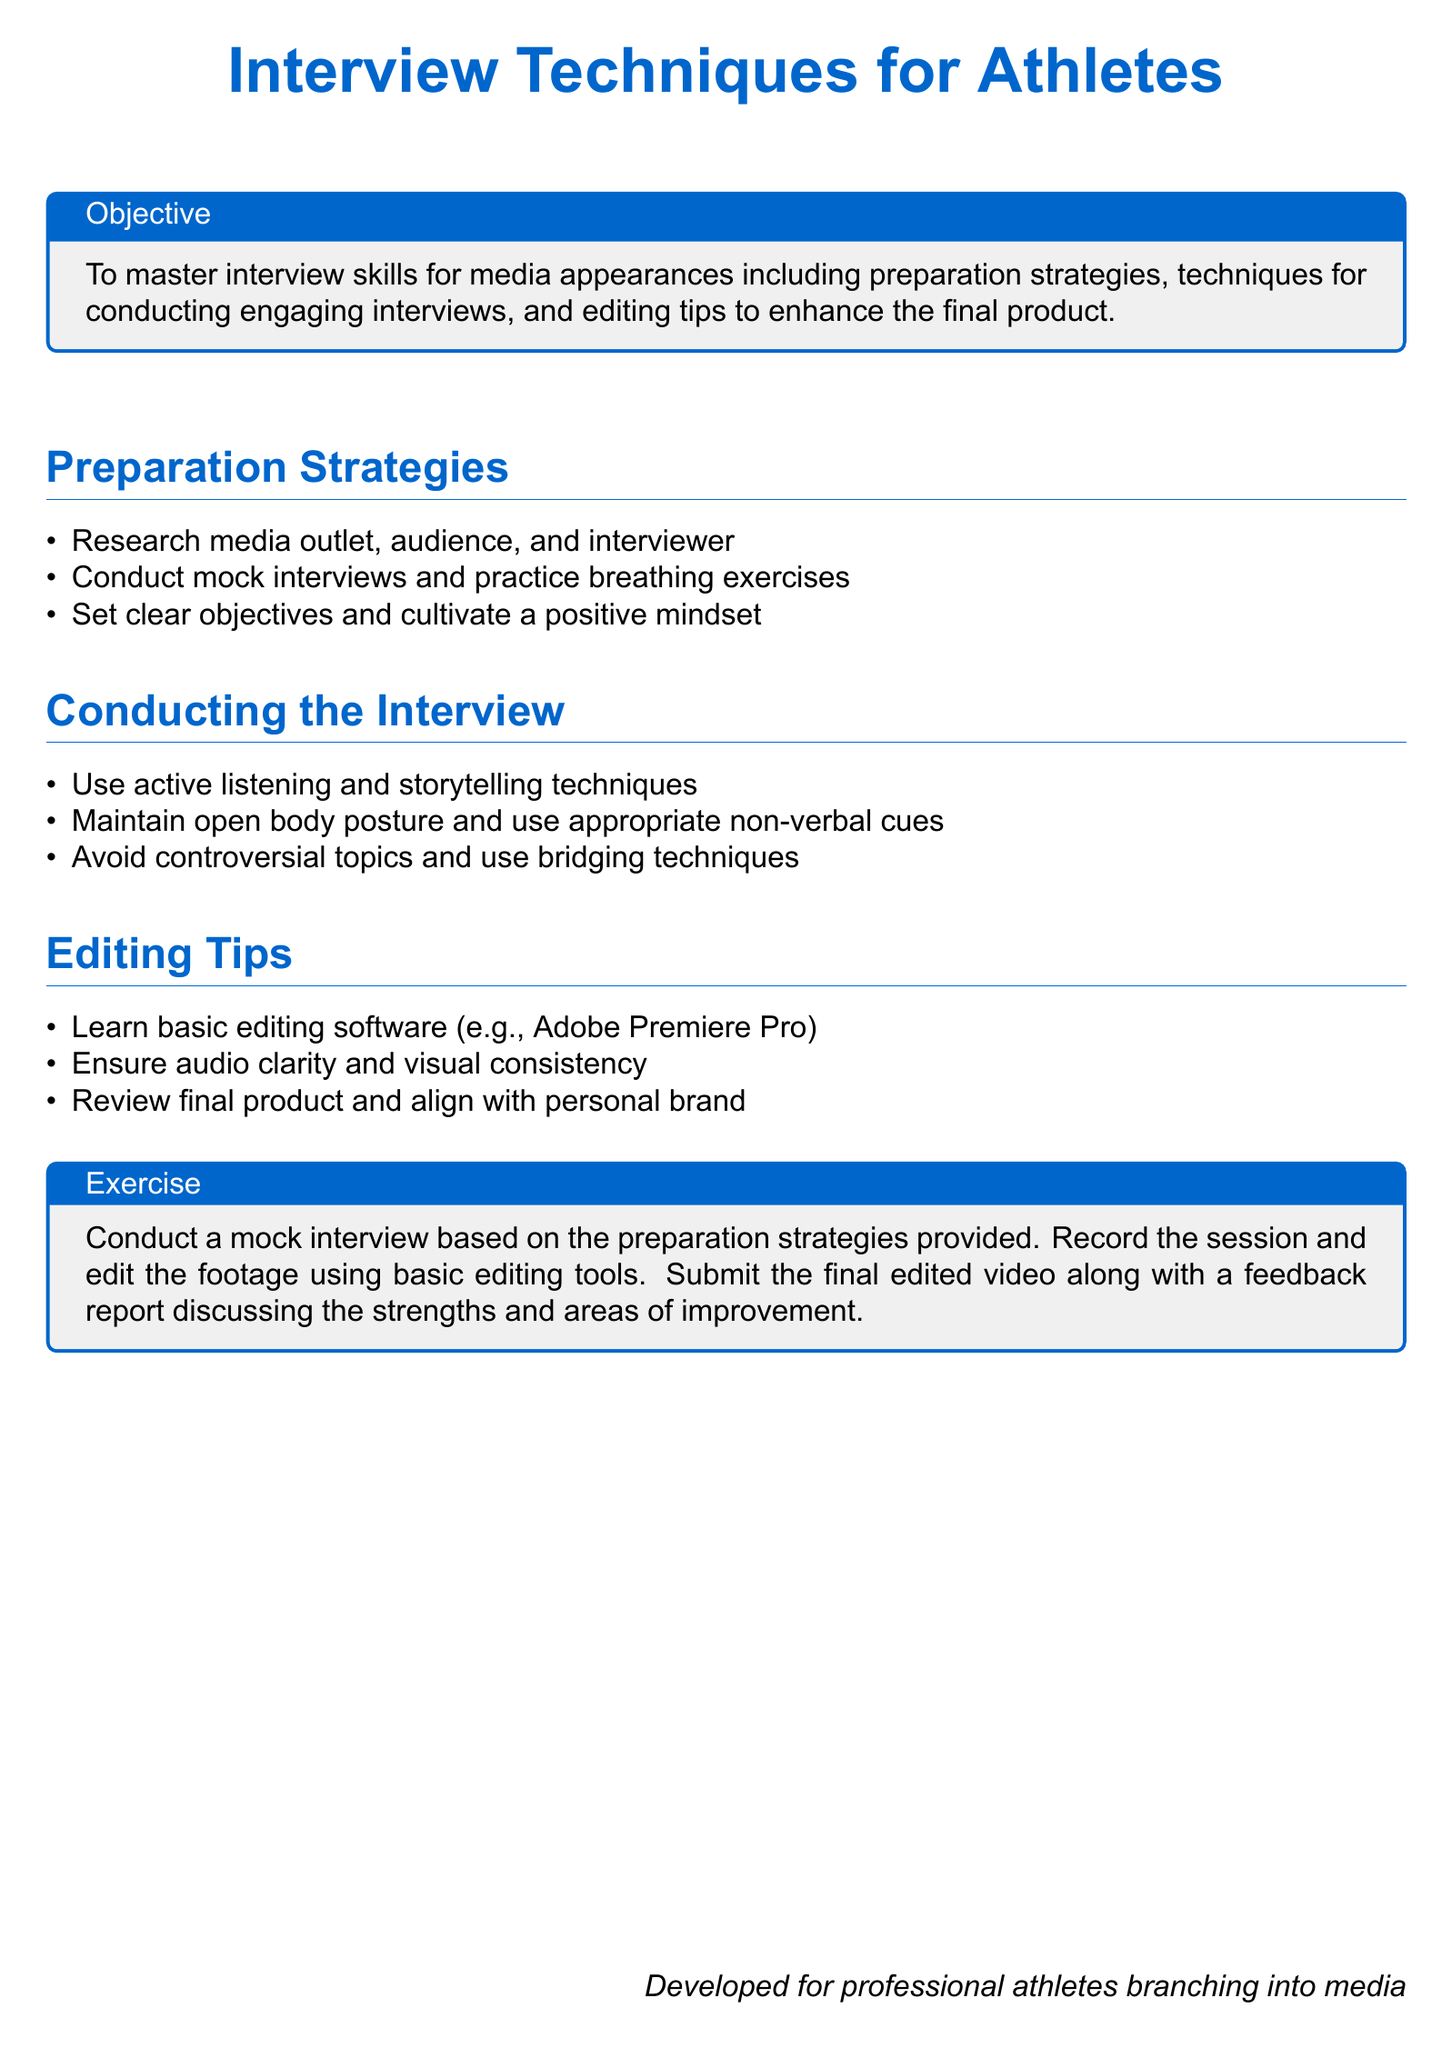what is the title of the document? The title of the document is specified at the beginning with the phrase "Interview Techniques for Athletes."
Answer: Interview Techniques for Athletes what is the main objective of the document? The main objective is stated in the box labeled "Objective" at the beginning, which outlines the overall goal of the document.
Answer: To master interview skills for media appearances name one preparation strategy mentioned in the document. The document lists several strategies under "Preparation Strategies," and only one is needed for the answer.
Answer: Research media outlet what editing software is mentioned for enhancing interviews? The document specifically mentions basic editing software in the "Editing Tips" section.
Answer: Adobe Premiere Pro how many main sections are included in the document? The document includes three main sections: "Preparation Strategies," "Conducting the Interview," and "Editing Tips."
Answer: 3 what type of posture should be maintained during the interview? The document advises on body posture in the "Conducting the Interview" section.
Answer: Open body posture what should be reviewed in the final product? The document states that the final product should be reviewed to align with personal brand and ensures audio clarity.
Answer: Final product what is the final exercise suggested in the document? The "Exercise" box details the activity for practitioners to conduct mock interviews and edit footage.
Answer: Conduct a mock interview 